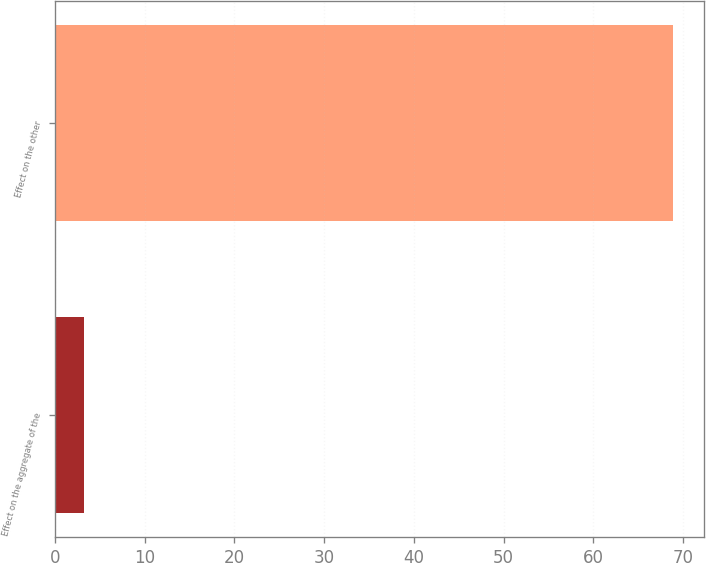<chart> <loc_0><loc_0><loc_500><loc_500><bar_chart><fcel>Effect on the aggregate of the<fcel>Effect on the other<nl><fcel>3.2<fcel>68.9<nl></chart> 